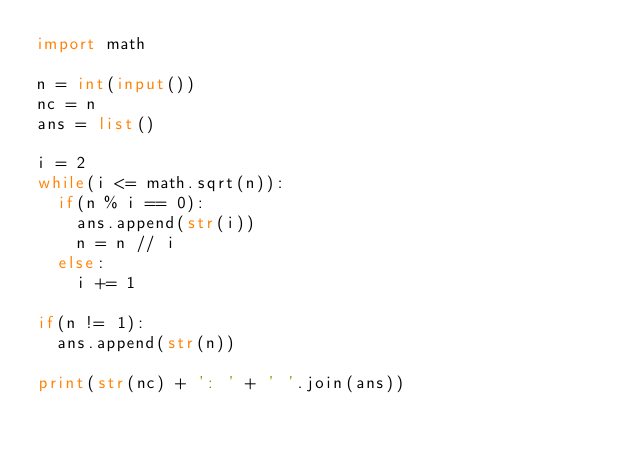Convert code to text. <code><loc_0><loc_0><loc_500><loc_500><_Python_>import math

n = int(input())
nc = n
ans = list()

i = 2
while(i <= math.sqrt(n)):
  if(n % i == 0):
    ans.append(str(i))
    n = n // i
  else:
    i += 1
    
if(n != 1):
  ans.append(str(n))

print(str(nc) + ': ' + ' '.join(ans))
</code> 